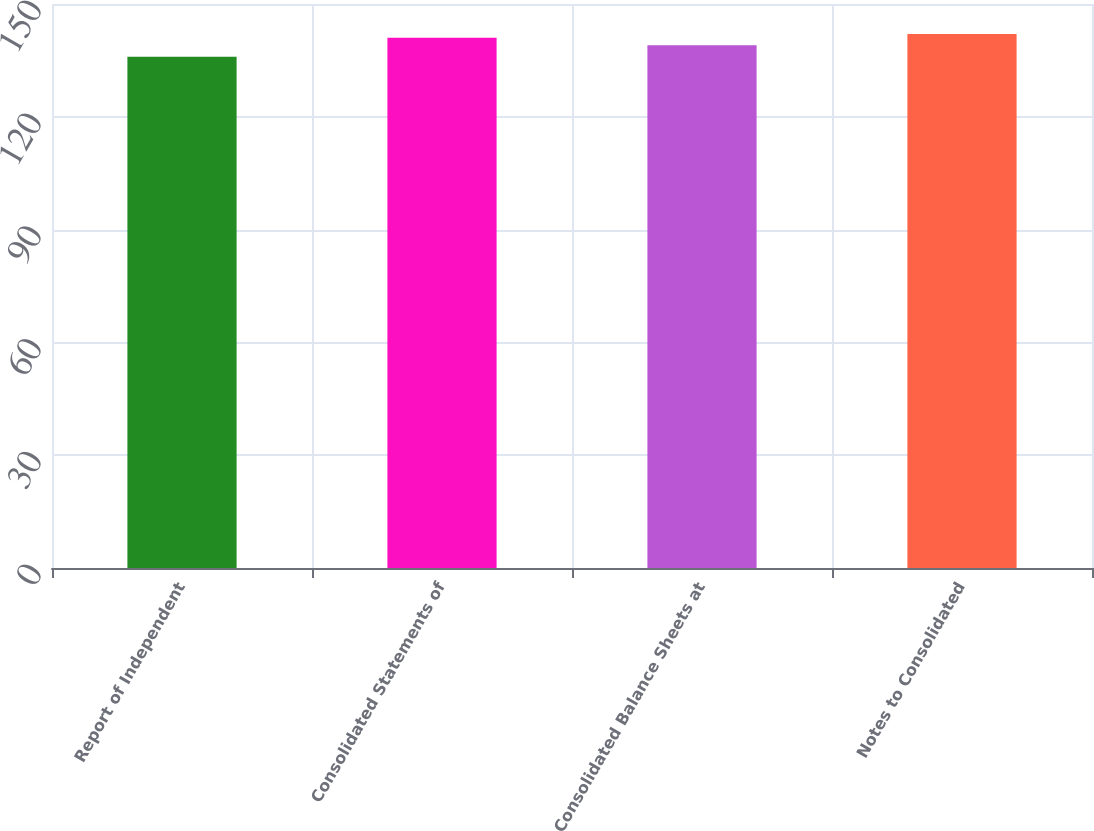<chart> <loc_0><loc_0><loc_500><loc_500><bar_chart><fcel>Report of Independent<fcel>Consolidated Statements of<fcel>Consolidated Balance Sheets at<fcel>Notes to Consolidated<nl><fcel>136<fcel>141<fcel>139<fcel>142<nl></chart> 